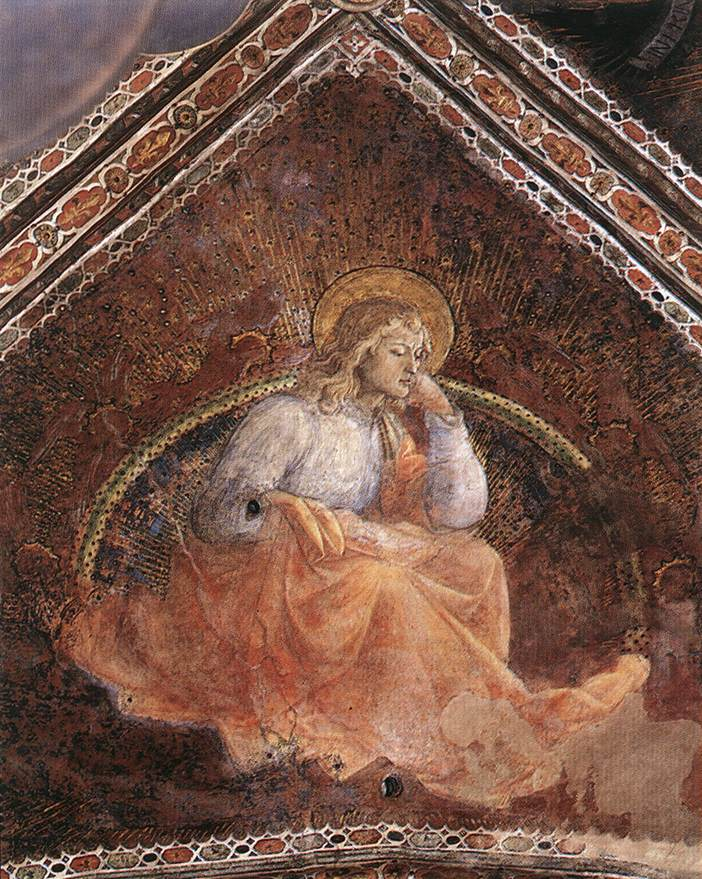What is the symbolism behind the colors used in the image? In this image, the colors are rich with symbolism. The white robe worn by the angel signifies purity, innocence, and heavenly grace. The golden halo and accents symbolize divinity and holiness, marking the angel as a sacred and revered figure. The dark red background creates a dramatic contrast, highlighting the angel's aura of light and suggesting themes of sacrifice, love, and divine power. Golden accents further enhance the richness and depth of the scene, adding a sense of timelessness and reverence typical of Renaissance religious artwork. 